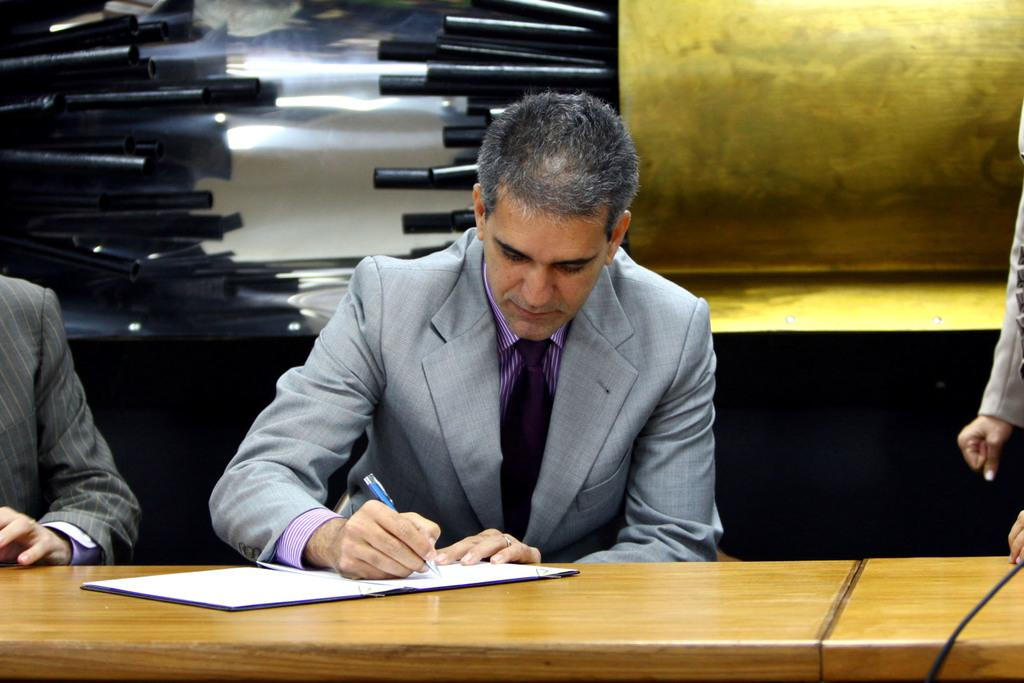Who is present in the image? There is a person in the image. What is the person wearing? The person is wearing a grey coat. What is the person doing in the image? The person is writing with a pen. What is the person writing on? The person is writing on a book. What furniture is visible in the image? There is a table in the image. What can be seen in the background of the image? There is a banner in the background of the image. What type of quartz can be seen on the table in the image? There is no quartz present on the table in the image. Can you tell me how many animals are visible in the zoo in the image? There is no zoo present in the image. 